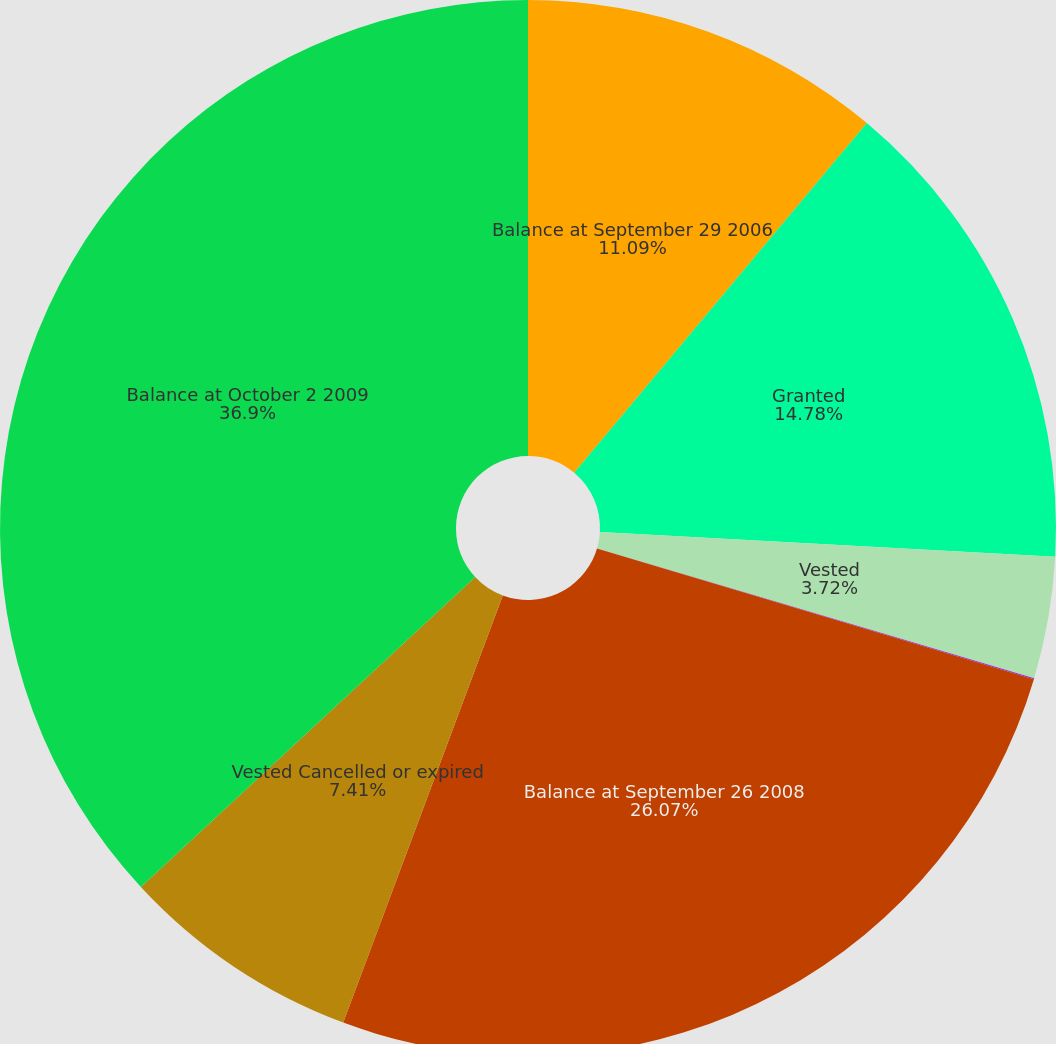Convert chart. <chart><loc_0><loc_0><loc_500><loc_500><pie_chart><fcel>Balance at September 29 2006<fcel>Granted<fcel>Vested<fcel>Cancelled or expired Balance<fcel>Balance at September 26 2008<fcel>Vested Cancelled or expired<fcel>Balance at October 2 2009<nl><fcel>11.09%<fcel>14.78%<fcel>3.72%<fcel>0.03%<fcel>26.07%<fcel>7.41%<fcel>36.9%<nl></chart> 